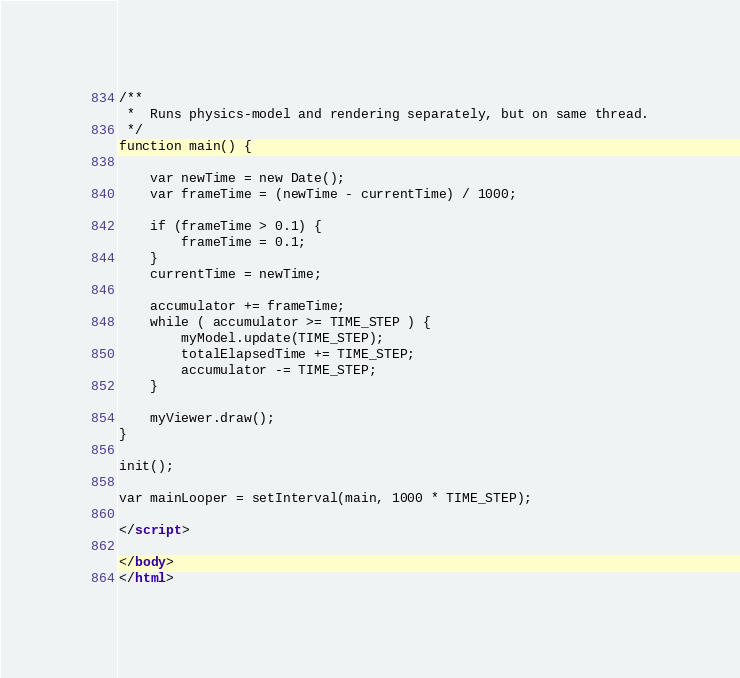<code> <loc_0><loc_0><loc_500><loc_500><_HTML_>
/**
 * 	Runs physics-model and rendering separately, but on same thread.
 */
function main() {

	var newTime = new Date();
	var frameTime = (newTime - currentTime) / 1000;

	if (frameTime > 0.1) {
		frameTime = 0.1;
	}
	currentTime = newTime;

	accumulator += frameTime;
	while ( accumulator >= TIME_STEP ) {
		myModel.update(TIME_STEP);
		totalElapsedTime += TIME_STEP;
		accumulator -= TIME_STEP;
	}

	myViewer.draw();
}

init();

var mainLooper = setInterval(main, 1000 * TIME_STEP);

</script>

</body>
</html>
</code> 